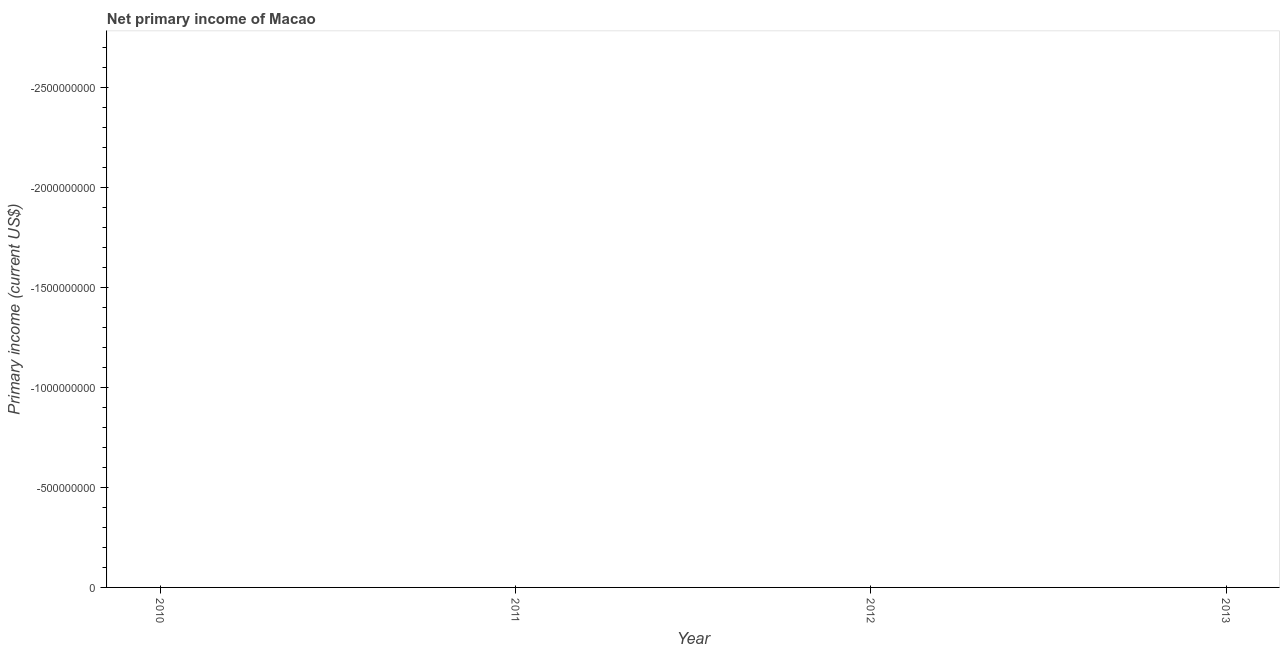What is the amount of primary income in 2011?
Ensure brevity in your answer.  0. What is the average amount of primary income per year?
Offer a terse response. 0. In how many years, is the amount of primary income greater than the average amount of primary income taken over all years?
Give a very brief answer. 0. How many years are there in the graph?
Your response must be concise. 4. Does the graph contain any zero values?
Your response must be concise. Yes. Does the graph contain grids?
Give a very brief answer. No. What is the title of the graph?
Provide a short and direct response. Net primary income of Macao. What is the label or title of the X-axis?
Provide a short and direct response. Year. What is the label or title of the Y-axis?
Your answer should be very brief. Primary income (current US$). What is the Primary income (current US$) in 2013?
Provide a succinct answer. 0. 